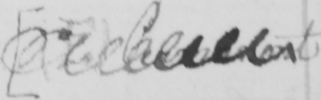What text is written in this handwritten line? <gap/> 